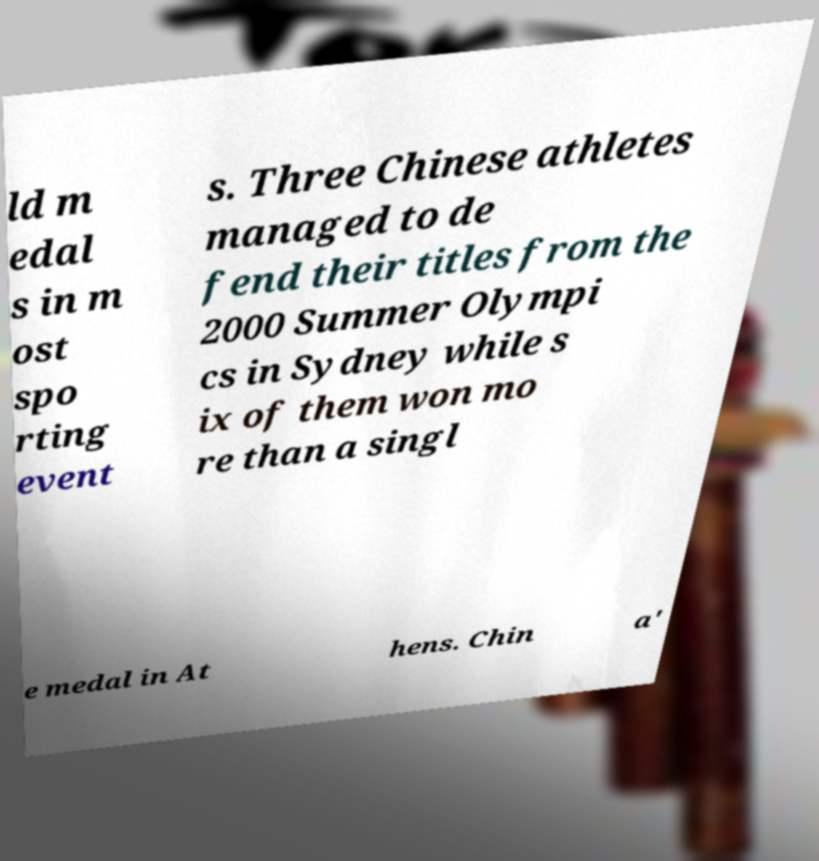For documentation purposes, I need the text within this image transcribed. Could you provide that? ld m edal s in m ost spo rting event s. Three Chinese athletes managed to de fend their titles from the 2000 Summer Olympi cs in Sydney while s ix of them won mo re than a singl e medal in At hens. Chin a' 